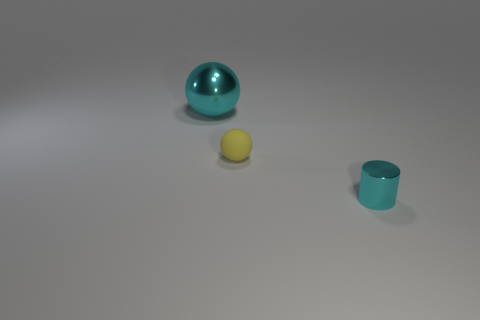Is there anything else that is made of the same material as the yellow thing?
Make the answer very short. No. There is a big thing that is the same shape as the tiny yellow rubber thing; what is its material?
Offer a very short reply. Metal. How many metal things are the same color as the tiny rubber object?
Offer a very short reply. 0. What size is the object that is the same material as the cyan ball?
Make the answer very short. Small. What number of green objects are tiny rubber things or big shiny balls?
Ensure brevity in your answer.  0. There is a cyan object that is behind the shiny cylinder; what number of big cyan metal things are in front of it?
Your response must be concise. 0. Are there more cyan objects that are right of the large cyan shiny thing than rubber balls that are right of the tiny rubber object?
Ensure brevity in your answer.  Yes. What is the yellow ball made of?
Offer a terse response. Rubber. Is there a thing that has the same size as the rubber sphere?
Ensure brevity in your answer.  Yes. What material is the yellow sphere that is the same size as the cyan cylinder?
Your answer should be very brief. Rubber. 